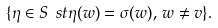Convert formula to latex. <formula><loc_0><loc_0><loc_500><loc_500>\{ \eta \in S \ s t \eta ( w ) = \sigma ( w ) , \, w \neq v \} .</formula> 